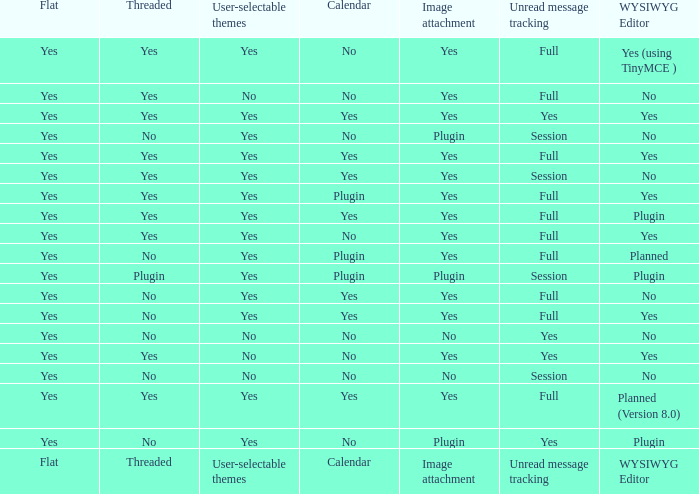Which wysiwyg editor comes with an image attachment feature and a calendar plugin? Yes, Planned. 